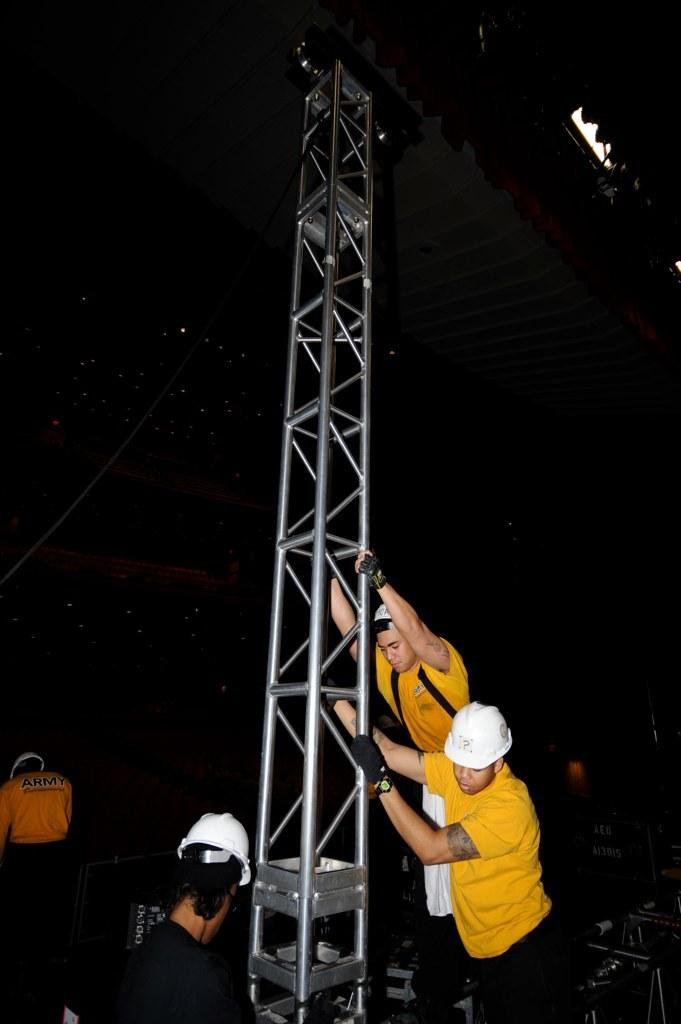How many people are in the image? There are three persons in the image. What are the persons holding in the image? The persons are holding a pole. What type of clothing are the persons wearing? The persons are wearing t-shirts. What protective gear are the persons wearing? The persons are wearing helmets. What additional feature can be seen in the top right corner of the image? There are focus lights visible in the top right corner of the image. What type of rifle is the person in the middle holding in the image? There is no rifle present in the image; the persons are holding a pole. What type of show is the person on the left participating in? There is no indication of a show in the image; the persons are simply holding a pole. 